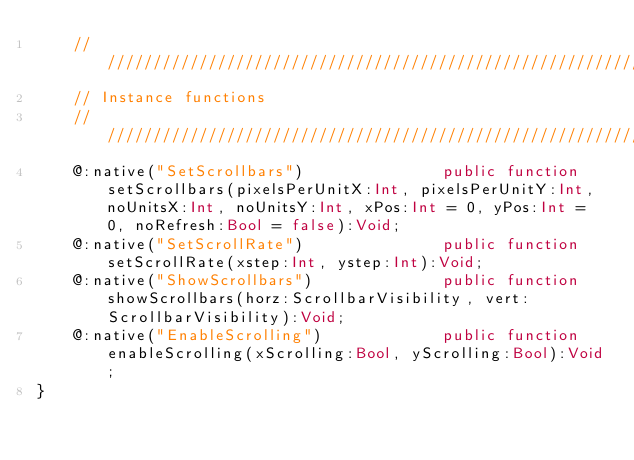Convert code to text. <code><loc_0><loc_0><loc_500><loc_500><_Haxe_>    //////////////////////////////////////////////////////////////////////////////////////////////////////////
    // Instance functions
    //////////////////////////////////////////////////////////////////////////////////////////////////////////
    @:native("SetScrollbars")               public function setScrollbars(pixelsPerUnitX:Int, pixelsPerUnitY:Int, noUnitsX:Int, noUnitsY:Int, xPos:Int = 0, yPos:Int = 0, noRefresh:Bool = false):Void;
    @:native("SetScrollRate")               public function setScrollRate(xstep:Int, ystep:Int):Void;
    @:native("ShowScrollbars")              public function showScrollbars(horz:ScrollbarVisibility, vert:ScrollbarVisibility):Void;
    @:native("EnableScrolling")             public function enableScrolling(xScrolling:Bool, yScrolling:Bool):Void;
}
</code> 